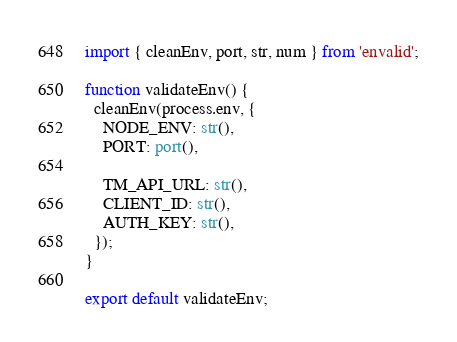<code> <loc_0><loc_0><loc_500><loc_500><_TypeScript_>import { cleanEnv, port, str, num } from 'envalid';

function validateEnv() {
  cleanEnv(process.env, {
    NODE_ENV: str(),
    PORT: port(),

    TM_API_URL: str(),
    CLIENT_ID: str(),
    AUTH_KEY: str(),
  });
}

export default validateEnv;
</code> 